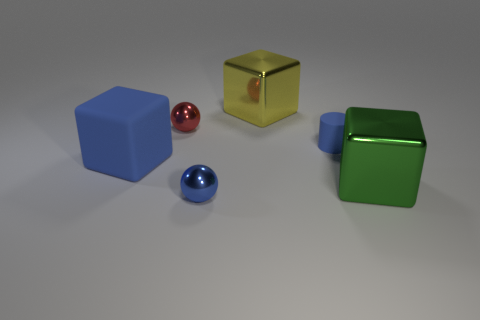Add 4 small purple matte balls. How many objects exist? 10 Subtract all balls. How many objects are left? 4 Add 4 red balls. How many red balls exist? 5 Subtract 0 gray balls. How many objects are left? 6 Subtract all tiny blue rubber objects. Subtract all big yellow cubes. How many objects are left? 4 Add 1 large blue cubes. How many large blue cubes are left? 2 